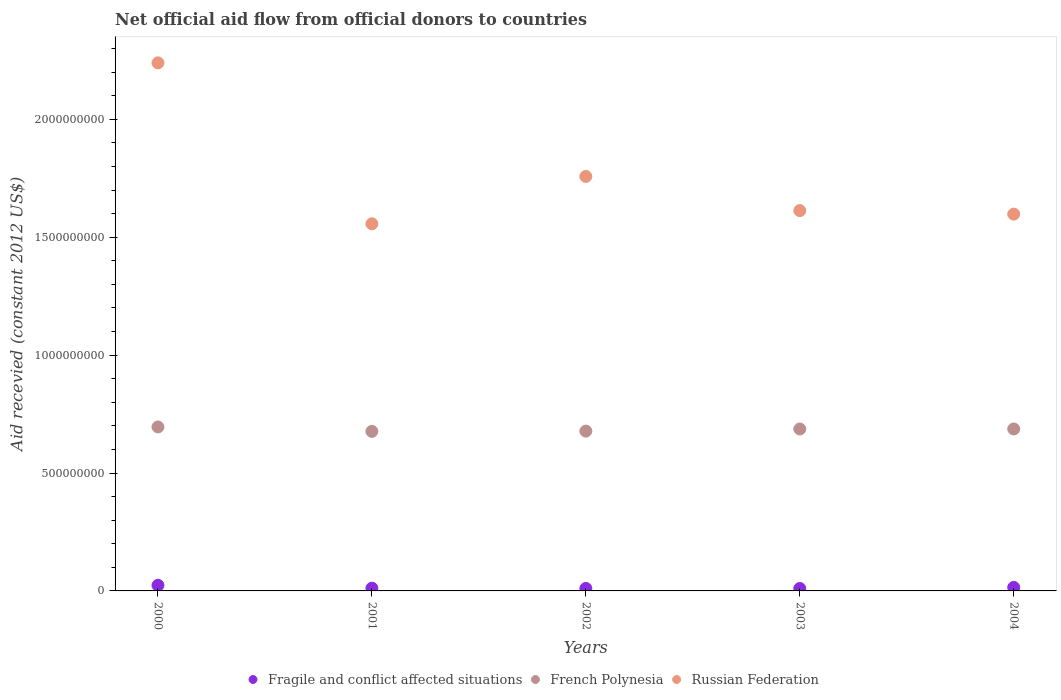Is the number of dotlines equal to the number of legend labels?
Offer a very short reply. Yes. What is the total aid received in Fragile and conflict affected situations in 2003?
Offer a very short reply. 1.03e+07. Across all years, what is the maximum total aid received in Russian Federation?
Provide a succinct answer. 2.24e+09. Across all years, what is the minimum total aid received in French Polynesia?
Provide a short and direct response. 6.76e+08. What is the total total aid received in Fragile and conflict affected situations in the graph?
Ensure brevity in your answer.  7.14e+07. What is the difference between the total aid received in French Polynesia in 2000 and that in 2004?
Offer a very short reply. 8.54e+06. What is the difference between the total aid received in French Polynesia in 2004 and the total aid received in Russian Federation in 2001?
Offer a terse response. -8.70e+08. What is the average total aid received in Fragile and conflict affected situations per year?
Ensure brevity in your answer.  1.43e+07. In the year 2001, what is the difference between the total aid received in French Polynesia and total aid received in Russian Federation?
Your response must be concise. -8.80e+08. What is the ratio of the total aid received in Russian Federation in 2001 to that in 2004?
Your answer should be very brief. 0.97. Is the total aid received in French Polynesia in 2000 less than that in 2002?
Keep it short and to the point. No. Is the difference between the total aid received in French Polynesia in 2000 and 2001 greater than the difference between the total aid received in Russian Federation in 2000 and 2001?
Your answer should be compact. No. What is the difference between the highest and the second highest total aid received in French Polynesia?
Your response must be concise. 8.54e+06. What is the difference between the highest and the lowest total aid received in Russian Federation?
Make the answer very short. 6.83e+08. Is it the case that in every year, the sum of the total aid received in French Polynesia and total aid received in Russian Federation  is greater than the total aid received in Fragile and conflict affected situations?
Ensure brevity in your answer.  Yes. Is the total aid received in Fragile and conflict affected situations strictly greater than the total aid received in French Polynesia over the years?
Ensure brevity in your answer.  No. How many years are there in the graph?
Give a very brief answer. 5. What is the difference between two consecutive major ticks on the Y-axis?
Provide a succinct answer. 5.00e+08. Are the values on the major ticks of Y-axis written in scientific E-notation?
Provide a short and direct response. No. Where does the legend appear in the graph?
Ensure brevity in your answer.  Bottom center. What is the title of the graph?
Make the answer very short. Net official aid flow from official donors to countries. What is the label or title of the X-axis?
Your answer should be very brief. Years. What is the label or title of the Y-axis?
Provide a succinct answer. Aid recevied (constant 2012 US$). What is the Aid recevied (constant 2012 US$) in Fragile and conflict affected situations in 2000?
Your answer should be compact. 2.38e+07. What is the Aid recevied (constant 2012 US$) of French Polynesia in 2000?
Provide a short and direct response. 6.95e+08. What is the Aid recevied (constant 2012 US$) in Russian Federation in 2000?
Your response must be concise. 2.24e+09. What is the Aid recevied (constant 2012 US$) in Fragile and conflict affected situations in 2001?
Your answer should be compact. 1.17e+07. What is the Aid recevied (constant 2012 US$) of French Polynesia in 2001?
Provide a short and direct response. 6.76e+08. What is the Aid recevied (constant 2012 US$) in Russian Federation in 2001?
Offer a terse response. 1.56e+09. What is the Aid recevied (constant 2012 US$) of Fragile and conflict affected situations in 2002?
Ensure brevity in your answer.  1.05e+07. What is the Aid recevied (constant 2012 US$) in French Polynesia in 2002?
Keep it short and to the point. 6.78e+08. What is the Aid recevied (constant 2012 US$) of Russian Federation in 2002?
Your answer should be compact. 1.76e+09. What is the Aid recevied (constant 2012 US$) in Fragile and conflict affected situations in 2003?
Offer a terse response. 1.03e+07. What is the Aid recevied (constant 2012 US$) of French Polynesia in 2003?
Your response must be concise. 6.87e+08. What is the Aid recevied (constant 2012 US$) in Russian Federation in 2003?
Offer a very short reply. 1.61e+09. What is the Aid recevied (constant 2012 US$) in Fragile and conflict affected situations in 2004?
Offer a terse response. 1.50e+07. What is the Aid recevied (constant 2012 US$) in French Polynesia in 2004?
Provide a succinct answer. 6.87e+08. What is the Aid recevied (constant 2012 US$) in Russian Federation in 2004?
Your answer should be very brief. 1.60e+09. Across all years, what is the maximum Aid recevied (constant 2012 US$) in Fragile and conflict affected situations?
Your answer should be compact. 2.38e+07. Across all years, what is the maximum Aid recevied (constant 2012 US$) in French Polynesia?
Make the answer very short. 6.95e+08. Across all years, what is the maximum Aid recevied (constant 2012 US$) of Russian Federation?
Your response must be concise. 2.24e+09. Across all years, what is the minimum Aid recevied (constant 2012 US$) of Fragile and conflict affected situations?
Keep it short and to the point. 1.03e+07. Across all years, what is the minimum Aid recevied (constant 2012 US$) in French Polynesia?
Your answer should be very brief. 6.76e+08. Across all years, what is the minimum Aid recevied (constant 2012 US$) of Russian Federation?
Ensure brevity in your answer.  1.56e+09. What is the total Aid recevied (constant 2012 US$) of Fragile and conflict affected situations in the graph?
Offer a terse response. 7.14e+07. What is the total Aid recevied (constant 2012 US$) of French Polynesia in the graph?
Provide a short and direct response. 3.42e+09. What is the total Aid recevied (constant 2012 US$) of Russian Federation in the graph?
Your response must be concise. 8.76e+09. What is the difference between the Aid recevied (constant 2012 US$) in Fragile and conflict affected situations in 2000 and that in 2001?
Make the answer very short. 1.21e+07. What is the difference between the Aid recevied (constant 2012 US$) of French Polynesia in 2000 and that in 2001?
Offer a terse response. 1.88e+07. What is the difference between the Aid recevied (constant 2012 US$) of Russian Federation in 2000 and that in 2001?
Make the answer very short. 6.83e+08. What is the difference between the Aid recevied (constant 2012 US$) in Fragile and conflict affected situations in 2000 and that in 2002?
Your response must be concise. 1.33e+07. What is the difference between the Aid recevied (constant 2012 US$) in French Polynesia in 2000 and that in 2002?
Give a very brief answer. 1.77e+07. What is the difference between the Aid recevied (constant 2012 US$) in Russian Federation in 2000 and that in 2002?
Your answer should be compact. 4.82e+08. What is the difference between the Aid recevied (constant 2012 US$) of Fragile and conflict affected situations in 2000 and that in 2003?
Your answer should be compact. 1.34e+07. What is the difference between the Aid recevied (constant 2012 US$) of French Polynesia in 2000 and that in 2003?
Your answer should be compact. 8.64e+06. What is the difference between the Aid recevied (constant 2012 US$) of Russian Federation in 2000 and that in 2003?
Provide a short and direct response. 6.26e+08. What is the difference between the Aid recevied (constant 2012 US$) of Fragile and conflict affected situations in 2000 and that in 2004?
Keep it short and to the point. 8.78e+06. What is the difference between the Aid recevied (constant 2012 US$) in French Polynesia in 2000 and that in 2004?
Provide a succinct answer. 8.54e+06. What is the difference between the Aid recevied (constant 2012 US$) of Russian Federation in 2000 and that in 2004?
Give a very brief answer. 6.41e+08. What is the difference between the Aid recevied (constant 2012 US$) of Fragile and conflict affected situations in 2001 and that in 2002?
Make the answer very short. 1.22e+06. What is the difference between the Aid recevied (constant 2012 US$) of French Polynesia in 2001 and that in 2002?
Give a very brief answer. -1.13e+06. What is the difference between the Aid recevied (constant 2012 US$) of Russian Federation in 2001 and that in 2002?
Keep it short and to the point. -2.01e+08. What is the difference between the Aid recevied (constant 2012 US$) in Fragile and conflict affected situations in 2001 and that in 2003?
Make the answer very short. 1.39e+06. What is the difference between the Aid recevied (constant 2012 US$) of French Polynesia in 2001 and that in 2003?
Your response must be concise. -1.02e+07. What is the difference between the Aid recevied (constant 2012 US$) in Russian Federation in 2001 and that in 2003?
Provide a succinct answer. -5.60e+07. What is the difference between the Aid recevied (constant 2012 US$) of Fragile and conflict affected situations in 2001 and that in 2004?
Offer a terse response. -3.28e+06. What is the difference between the Aid recevied (constant 2012 US$) of French Polynesia in 2001 and that in 2004?
Offer a terse response. -1.03e+07. What is the difference between the Aid recevied (constant 2012 US$) in Russian Federation in 2001 and that in 2004?
Offer a terse response. -4.11e+07. What is the difference between the Aid recevied (constant 2012 US$) of French Polynesia in 2002 and that in 2003?
Offer a very short reply. -9.07e+06. What is the difference between the Aid recevied (constant 2012 US$) of Russian Federation in 2002 and that in 2003?
Your response must be concise. 1.45e+08. What is the difference between the Aid recevied (constant 2012 US$) of Fragile and conflict affected situations in 2002 and that in 2004?
Your response must be concise. -4.50e+06. What is the difference between the Aid recevied (constant 2012 US$) of French Polynesia in 2002 and that in 2004?
Your answer should be compact. -9.17e+06. What is the difference between the Aid recevied (constant 2012 US$) in Russian Federation in 2002 and that in 2004?
Provide a succinct answer. 1.60e+08. What is the difference between the Aid recevied (constant 2012 US$) of Fragile and conflict affected situations in 2003 and that in 2004?
Your answer should be compact. -4.67e+06. What is the difference between the Aid recevied (constant 2012 US$) of Russian Federation in 2003 and that in 2004?
Offer a very short reply. 1.50e+07. What is the difference between the Aid recevied (constant 2012 US$) in Fragile and conflict affected situations in 2000 and the Aid recevied (constant 2012 US$) in French Polynesia in 2001?
Provide a succinct answer. -6.53e+08. What is the difference between the Aid recevied (constant 2012 US$) of Fragile and conflict affected situations in 2000 and the Aid recevied (constant 2012 US$) of Russian Federation in 2001?
Your answer should be compact. -1.53e+09. What is the difference between the Aid recevied (constant 2012 US$) in French Polynesia in 2000 and the Aid recevied (constant 2012 US$) in Russian Federation in 2001?
Keep it short and to the point. -8.61e+08. What is the difference between the Aid recevied (constant 2012 US$) of Fragile and conflict affected situations in 2000 and the Aid recevied (constant 2012 US$) of French Polynesia in 2002?
Offer a very short reply. -6.54e+08. What is the difference between the Aid recevied (constant 2012 US$) of Fragile and conflict affected situations in 2000 and the Aid recevied (constant 2012 US$) of Russian Federation in 2002?
Ensure brevity in your answer.  -1.73e+09. What is the difference between the Aid recevied (constant 2012 US$) in French Polynesia in 2000 and the Aid recevied (constant 2012 US$) in Russian Federation in 2002?
Give a very brief answer. -1.06e+09. What is the difference between the Aid recevied (constant 2012 US$) in Fragile and conflict affected situations in 2000 and the Aid recevied (constant 2012 US$) in French Polynesia in 2003?
Ensure brevity in your answer.  -6.63e+08. What is the difference between the Aid recevied (constant 2012 US$) of Fragile and conflict affected situations in 2000 and the Aid recevied (constant 2012 US$) of Russian Federation in 2003?
Give a very brief answer. -1.59e+09. What is the difference between the Aid recevied (constant 2012 US$) of French Polynesia in 2000 and the Aid recevied (constant 2012 US$) of Russian Federation in 2003?
Your answer should be compact. -9.17e+08. What is the difference between the Aid recevied (constant 2012 US$) in Fragile and conflict affected situations in 2000 and the Aid recevied (constant 2012 US$) in French Polynesia in 2004?
Your answer should be compact. -6.63e+08. What is the difference between the Aid recevied (constant 2012 US$) of Fragile and conflict affected situations in 2000 and the Aid recevied (constant 2012 US$) of Russian Federation in 2004?
Your response must be concise. -1.57e+09. What is the difference between the Aid recevied (constant 2012 US$) of French Polynesia in 2000 and the Aid recevied (constant 2012 US$) of Russian Federation in 2004?
Your response must be concise. -9.02e+08. What is the difference between the Aid recevied (constant 2012 US$) in Fragile and conflict affected situations in 2001 and the Aid recevied (constant 2012 US$) in French Polynesia in 2002?
Your answer should be compact. -6.66e+08. What is the difference between the Aid recevied (constant 2012 US$) of Fragile and conflict affected situations in 2001 and the Aid recevied (constant 2012 US$) of Russian Federation in 2002?
Offer a very short reply. -1.75e+09. What is the difference between the Aid recevied (constant 2012 US$) of French Polynesia in 2001 and the Aid recevied (constant 2012 US$) of Russian Federation in 2002?
Provide a short and direct response. -1.08e+09. What is the difference between the Aid recevied (constant 2012 US$) in Fragile and conflict affected situations in 2001 and the Aid recevied (constant 2012 US$) in French Polynesia in 2003?
Provide a short and direct response. -6.75e+08. What is the difference between the Aid recevied (constant 2012 US$) in Fragile and conflict affected situations in 2001 and the Aid recevied (constant 2012 US$) in Russian Federation in 2003?
Offer a terse response. -1.60e+09. What is the difference between the Aid recevied (constant 2012 US$) in French Polynesia in 2001 and the Aid recevied (constant 2012 US$) in Russian Federation in 2003?
Ensure brevity in your answer.  -9.36e+08. What is the difference between the Aid recevied (constant 2012 US$) of Fragile and conflict affected situations in 2001 and the Aid recevied (constant 2012 US$) of French Polynesia in 2004?
Make the answer very short. -6.75e+08. What is the difference between the Aid recevied (constant 2012 US$) in Fragile and conflict affected situations in 2001 and the Aid recevied (constant 2012 US$) in Russian Federation in 2004?
Keep it short and to the point. -1.59e+09. What is the difference between the Aid recevied (constant 2012 US$) of French Polynesia in 2001 and the Aid recevied (constant 2012 US$) of Russian Federation in 2004?
Provide a short and direct response. -9.21e+08. What is the difference between the Aid recevied (constant 2012 US$) in Fragile and conflict affected situations in 2002 and the Aid recevied (constant 2012 US$) in French Polynesia in 2003?
Provide a succinct answer. -6.76e+08. What is the difference between the Aid recevied (constant 2012 US$) of Fragile and conflict affected situations in 2002 and the Aid recevied (constant 2012 US$) of Russian Federation in 2003?
Give a very brief answer. -1.60e+09. What is the difference between the Aid recevied (constant 2012 US$) of French Polynesia in 2002 and the Aid recevied (constant 2012 US$) of Russian Federation in 2003?
Provide a succinct answer. -9.35e+08. What is the difference between the Aid recevied (constant 2012 US$) in Fragile and conflict affected situations in 2002 and the Aid recevied (constant 2012 US$) in French Polynesia in 2004?
Offer a terse response. -6.76e+08. What is the difference between the Aid recevied (constant 2012 US$) in Fragile and conflict affected situations in 2002 and the Aid recevied (constant 2012 US$) in Russian Federation in 2004?
Provide a succinct answer. -1.59e+09. What is the difference between the Aid recevied (constant 2012 US$) of French Polynesia in 2002 and the Aid recevied (constant 2012 US$) of Russian Federation in 2004?
Your answer should be compact. -9.20e+08. What is the difference between the Aid recevied (constant 2012 US$) of Fragile and conflict affected situations in 2003 and the Aid recevied (constant 2012 US$) of French Polynesia in 2004?
Keep it short and to the point. -6.76e+08. What is the difference between the Aid recevied (constant 2012 US$) in Fragile and conflict affected situations in 2003 and the Aid recevied (constant 2012 US$) in Russian Federation in 2004?
Provide a succinct answer. -1.59e+09. What is the difference between the Aid recevied (constant 2012 US$) in French Polynesia in 2003 and the Aid recevied (constant 2012 US$) in Russian Federation in 2004?
Your answer should be compact. -9.11e+08. What is the average Aid recevied (constant 2012 US$) in Fragile and conflict affected situations per year?
Offer a terse response. 1.43e+07. What is the average Aid recevied (constant 2012 US$) of French Polynesia per year?
Ensure brevity in your answer.  6.85e+08. What is the average Aid recevied (constant 2012 US$) of Russian Federation per year?
Ensure brevity in your answer.  1.75e+09. In the year 2000, what is the difference between the Aid recevied (constant 2012 US$) in Fragile and conflict affected situations and Aid recevied (constant 2012 US$) in French Polynesia?
Offer a very short reply. -6.72e+08. In the year 2000, what is the difference between the Aid recevied (constant 2012 US$) in Fragile and conflict affected situations and Aid recevied (constant 2012 US$) in Russian Federation?
Provide a short and direct response. -2.22e+09. In the year 2000, what is the difference between the Aid recevied (constant 2012 US$) in French Polynesia and Aid recevied (constant 2012 US$) in Russian Federation?
Your answer should be very brief. -1.54e+09. In the year 2001, what is the difference between the Aid recevied (constant 2012 US$) of Fragile and conflict affected situations and Aid recevied (constant 2012 US$) of French Polynesia?
Keep it short and to the point. -6.65e+08. In the year 2001, what is the difference between the Aid recevied (constant 2012 US$) in Fragile and conflict affected situations and Aid recevied (constant 2012 US$) in Russian Federation?
Offer a terse response. -1.55e+09. In the year 2001, what is the difference between the Aid recevied (constant 2012 US$) of French Polynesia and Aid recevied (constant 2012 US$) of Russian Federation?
Your answer should be very brief. -8.80e+08. In the year 2002, what is the difference between the Aid recevied (constant 2012 US$) in Fragile and conflict affected situations and Aid recevied (constant 2012 US$) in French Polynesia?
Keep it short and to the point. -6.67e+08. In the year 2002, what is the difference between the Aid recevied (constant 2012 US$) in Fragile and conflict affected situations and Aid recevied (constant 2012 US$) in Russian Federation?
Offer a very short reply. -1.75e+09. In the year 2002, what is the difference between the Aid recevied (constant 2012 US$) of French Polynesia and Aid recevied (constant 2012 US$) of Russian Federation?
Provide a short and direct response. -1.08e+09. In the year 2003, what is the difference between the Aid recevied (constant 2012 US$) in Fragile and conflict affected situations and Aid recevied (constant 2012 US$) in French Polynesia?
Offer a terse response. -6.76e+08. In the year 2003, what is the difference between the Aid recevied (constant 2012 US$) of Fragile and conflict affected situations and Aid recevied (constant 2012 US$) of Russian Federation?
Give a very brief answer. -1.60e+09. In the year 2003, what is the difference between the Aid recevied (constant 2012 US$) in French Polynesia and Aid recevied (constant 2012 US$) in Russian Federation?
Offer a terse response. -9.26e+08. In the year 2004, what is the difference between the Aid recevied (constant 2012 US$) in Fragile and conflict affected situations and Aid recevied (constant 2012 US$) in French Polynesia?
Ensure brevity in your answer.  -6.72e+08. In the year 2004, what is the difference between the Aid recevied (constant 2012 US$) in Fragile and conflict affected situations and Aid recevied (constant 2012 US$) in Russian Federation?
Offer a terse response. -1.58e+09. In the year 2004, what is the difference between the Aid recevied (constant 2012 US$) in French Polynesia and Aid recevied (constant 2012 US$) in Russian Federation?
Give a very brief answer. -9.11e+08. What is the ratio of the Aid recevied (constant 2012 US$) of Fragile and conflict affected situations in 2000 to that in 2001?
Give a very brief answer. 2.03. What is the ratio of the Aid recevied (constant 2012 US$) in French Polynesia in 2000 to that in 2001?
Offer a terse response. 1.03. What is the ratio of the Aid recevied (constant 2012 US$) of Russian Federation in 2000 to that in 2001?
Offer a very short reply. 1.44. What is the ratio of the Aid recevied (constant 2012 US$) of Fragile and conflict affected situations in 2000 to that in 2002?
Your answer should be compact. 2.26. What is the ratio of the Aid recevied (constant 2012 US$) in French Polynesia in 2000 to that in 2002?
Ensure brevity in your answer.  1.03. What is the ratio of the Aid recevied (constant 2012 US$) in Russian Federation in 2000 to that in 2002?
Provide a succinct answer. 1.27. What is the ratio of the Aid recevied (constant 2012 US$) in Fragile and conflict affected situations in 2000 to that in 2003?
Provide a short and direct response. 2.3. What is the ratio of the Aid recevied (constant 2012 US$) in French Polynesia in 2000 to that in 2003?
Ensure brevity in your answer.  1.01. What is the ratio of the Aid recevied (constant 2012 US$) of Russian Federation in 2000 to that in 2003?
Ensure brevity in your answer.  1.39. What is the ratio of the Aid recevied (constant 2012 US$) of Fragile and conflict affected situations in 2000 to that in 2004?
Make the answer very short. 1.58. What is the ratio of the Aid recevied (constant 2012 US$) in French Polynesia in 2000 to that in 2004?
Offer a terse response. 1.01. What is the ratio of the Aid recevied (constant 2012 US$) in Russian Federation in 2000 to that in 2004?
Provide a succinct answer. 1.4. What is the ratio of the Aid recevied (constant 2012 US$) of Fragile and conflict affected situations in 2001 to that in 2002?
Keep it short and to the point. 1.12. What is the ratio of the Aid recevied (constant 2012 US$) of French Polynesia in 2001 to that in 2002?
Offer a terse response. 1. What is the ratio of the Aid recevied (constant 2012 US$) in Russian Federation in 2001 to that in 2002?
Give a very brief answer. 0.89. What is the ratio of the Aid recevied (constant 2012 US$) in Fragile and conflict affected situations in 2001 to that in 2003?
Make the answer very short. 1.13. What is the ratio of the Aid recevied (constant 2012 US$) of French Polynesia in 2001 to that in 2003?
Offer a very short reply. 0.99. What is the ratio of the Aid recevied (constant 2012 US$) of Russian Federation in 2001 to that in 2003?
Offer a terse response. 0.97. What is the ratio of the Aid recevied (constant 2012 US$) in Fragile and conflict affected situations in 2001 to that in 2004?
Give a very brief answer. 0.78. What is the ratio of the Aid recevied (constant 2012 US$) of Russian Federation in 2001 to that in 2004?
Your answer should be compact. 0.97. What is the ratio of the Aid recevied (constant 2012 US$) in Fragile and conflict affected situations in 2002 to that in 2003?
Offer a very short reply. 1.02. What is the ratio of the Aid recevied (constant 2012 US$) in Russian Federation in 2002 to that in 2003?
Provide a short and direct response. 1.09. What is the ratio of the Aid recevied (constant 2012 US$) in Fragile and conflict affected situations in 2002 to that in 2004?
Your answer should be compact. 0.7. What is the ratio of the Aid recevied (constant 2012 US$) of French Polynesia in 2002 to that in 2004?
Your answer should be compact. 0.99. What is the ratio of the Aid recevied (constant 2012 US$) in Fragile and conflict affected situations in 2003 to that in 2004?
Ensure brevity in your answer.  0.69. What is the ratio of the Aid recevied (constant 2012 US$) in French Polynesia in 2003 to that in 2004?
Offer a terse response. 1. What is the ratio of the Aid recevied (constant 2012 US$) in Russian Federation in 2003 to that in 2004?
Make the answer very short. 1.01. What is the difference between the highest and the second highest Aid recevied (constant 2012 US$) of Fragile and conflict affected situations?
Provide a succinct answer. 8.78e+06. What is the difference between the highest and the second highest Aid recevied (constant 2012 US$) in French Polynesia?
Keep it short and to the point. 8.54e+06. What is the difference between the highest and the second highest Aid recevied (constant 2012 US$) of Russian Federation?
Your response must be concise. 4.82e+08. What is the difference between the highest and the lowest Aid recevied (constant 2012 US$) in Fragile and conflict affected situations?
Your response must be concise. 1.34e+07. What is the difference between the highest and the lowest Aid recevied (constant 2012 US$) in French Polynesia?
Your answer should be very brief. 1.88e+07. What is the difference between the highest and the lowest Aid recevied (constant 2012 US$) of Russian Federation?
Keep it short and to the point. 6.83e+08. 